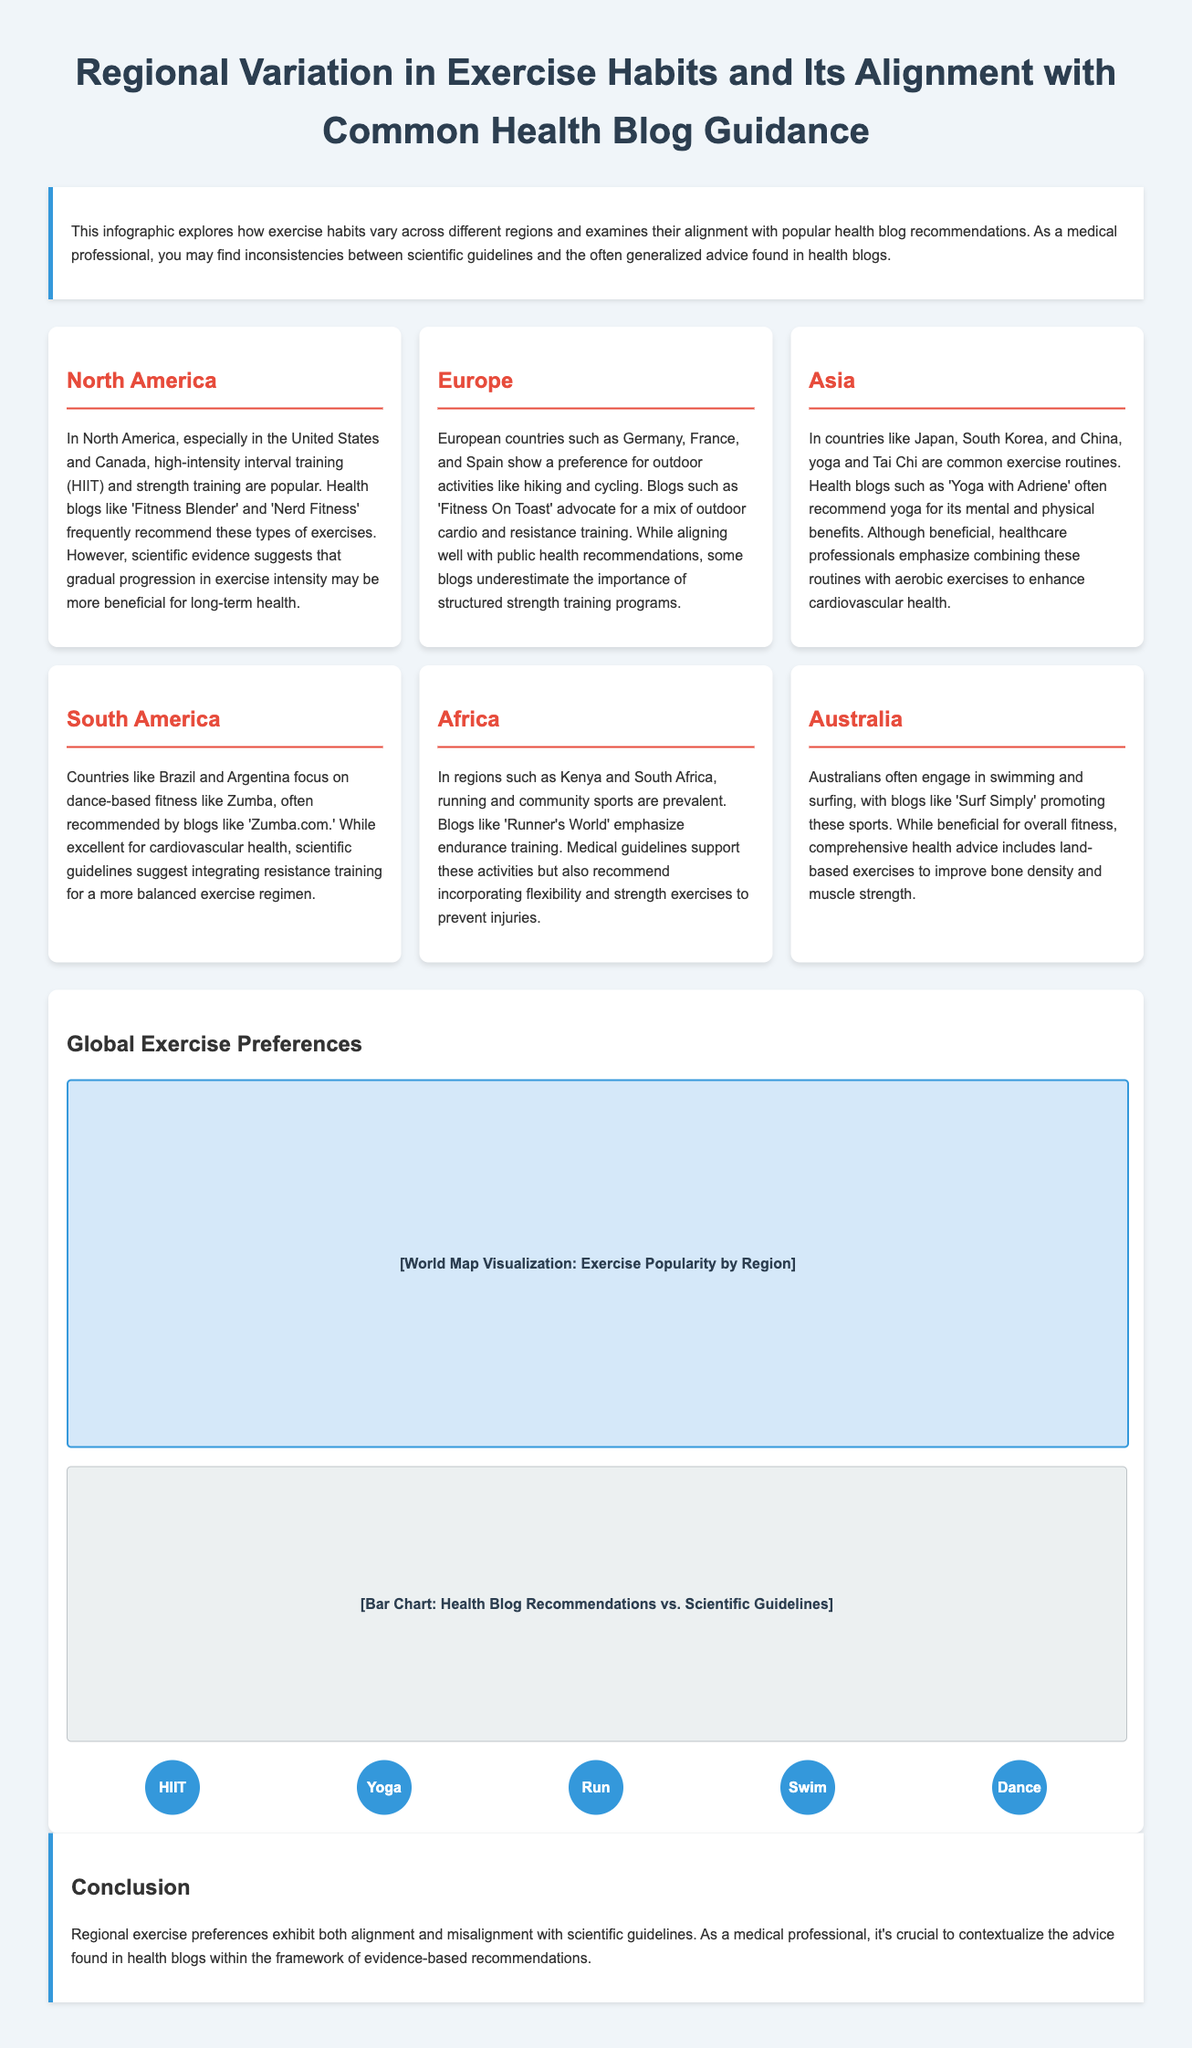what exercise types are popular in North America? The document states that high-intensity interval training (HIIT) and strength training are popular in North America.
Answer: HIIT and strength training which region prefers outdoor activities like hiking and cycling? The document specifies that European countries such as Germany, France, and Spain show a preference for outdoor activities.
Answer: Europe what health blog is mentioned in relation to yoga? The document identifies 'Yoga with Adriene' as a health blog that recommends yoga.
Answer: Yoga with Adriene which exercise is emphasized in South America? The document notes that countries like Brazil and Argentina focus on dance-based fitness like Zumba.
Answer: Zumba what is a scientific guideline recommendation for strength training in South America? The document indicates that scientific guidelines suggest integrating resistance training for a more balanced exercise regimen.
Answer: Integrating resistance training what does the conclusion highlight about regional exercise preferences? The conclusion states that regional exercise preferences exhibit both alignment and misalignment with scientific guidelines.
Answer: Alignment and misalignment which community is prevalent in running according to the document? The document refers to regions such as Kenya and South Africa, where running is prevalent.
Answer: Kenya and South Africa what overall fitness activity is popular in Australia? The document mentions swimming and surfing as popular fitness activities in Australia.
Answer: Swimming and surfing 